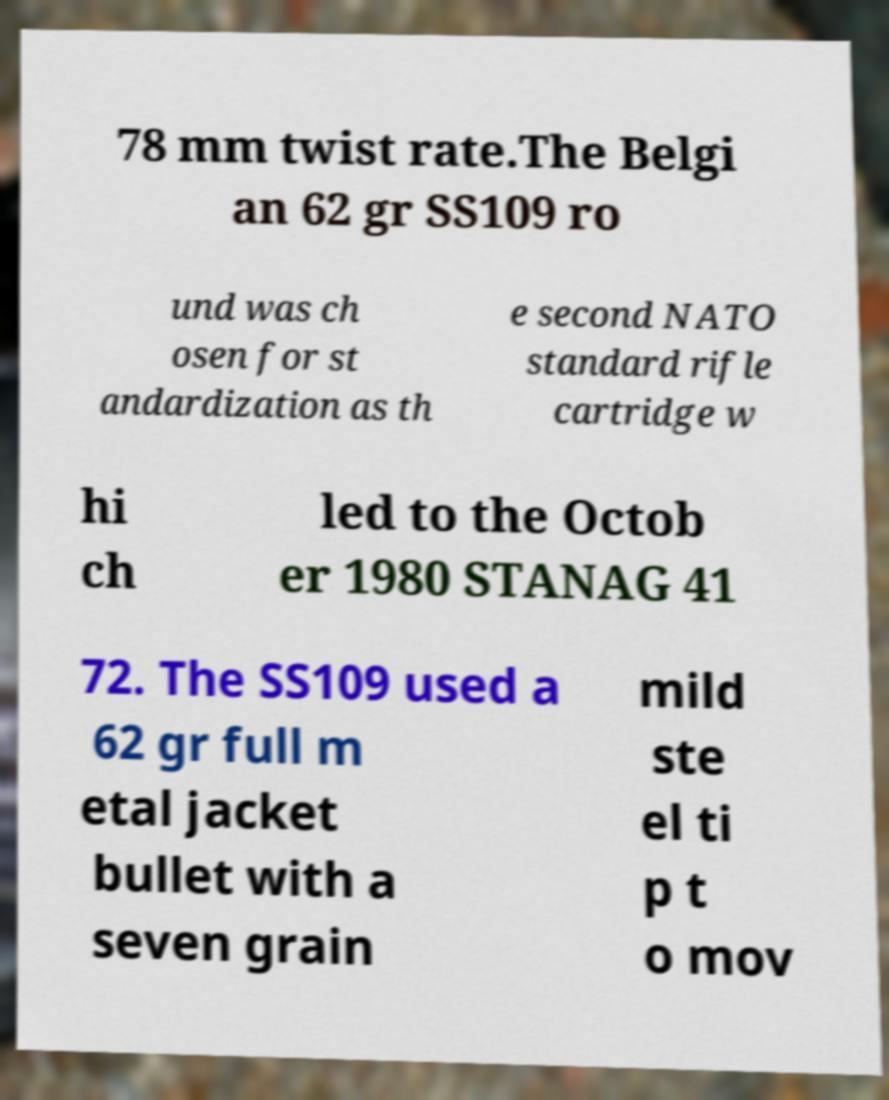Can you accurately transcribe the text from the provided image for me? 78 mm twist rate.The Belgi an 62 gr SS109 ro und was ch osen for st andardization as th e second NATO standard rifle cartridge w hi ch led to the Octob er 1980 STANAG 41 72. The SS109 used a 62 gr full m etal jacket bullet with a seven grain mild ste el ti p t o mov 